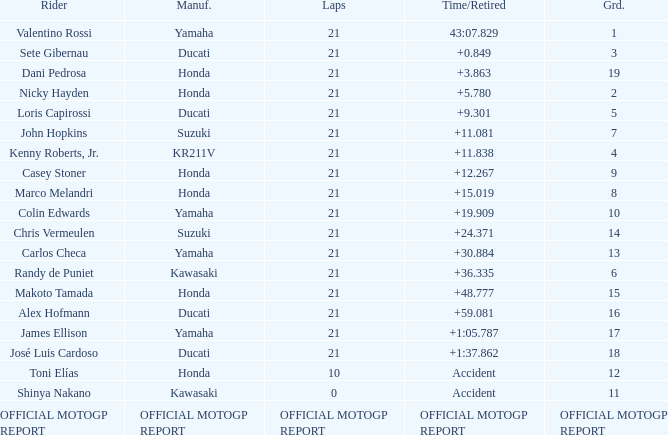WWhich rder had a vehicle manufactured by kr211v? Kenny Roberts, Jr. 